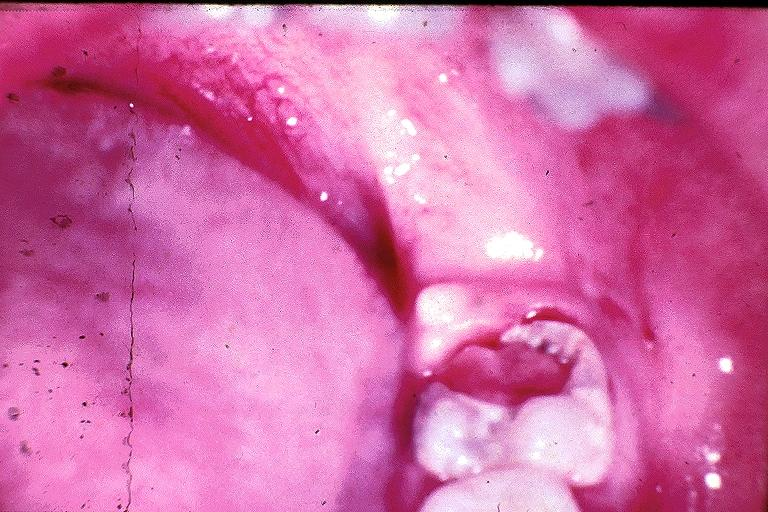s oral present?
Answer the question using a single word or phrase. Yes 